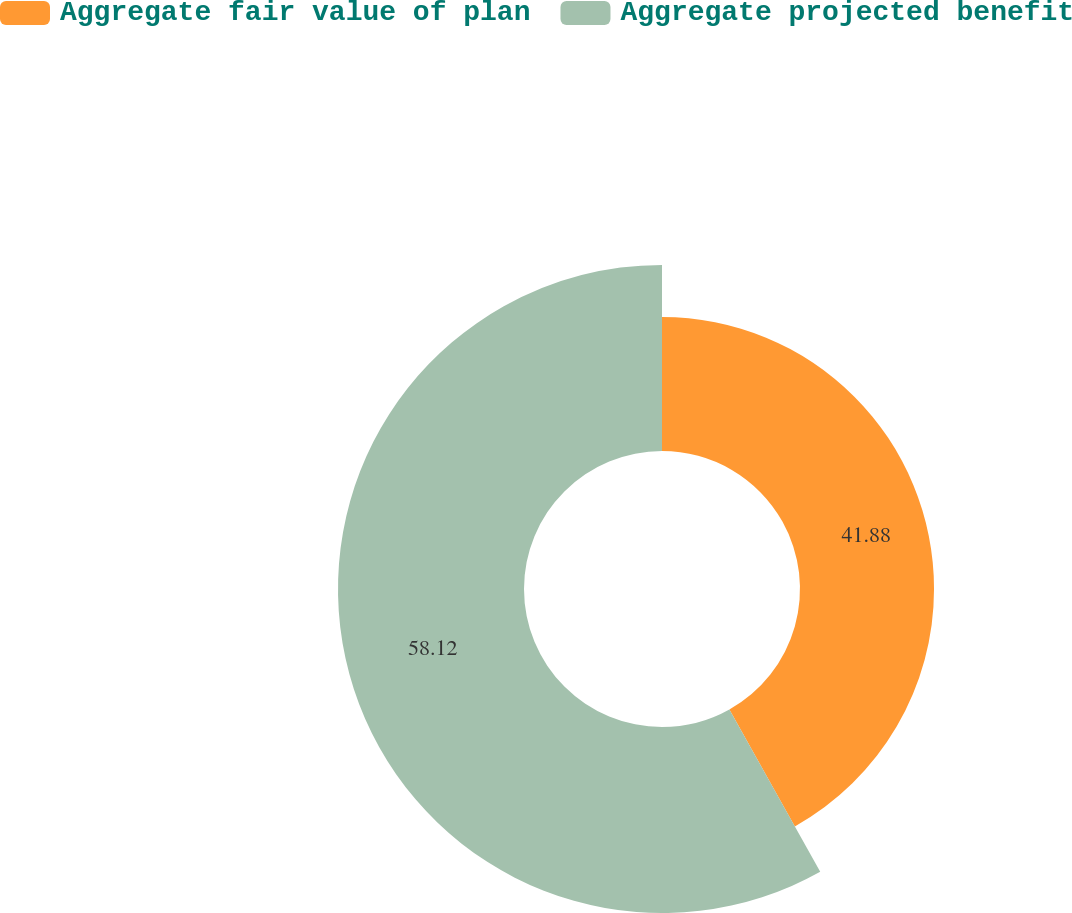Convert chart to OTSL. <chart><loc_0><loc_0><loc_500><loc_500><pie_chart><fcel>Aggregate fair value of plan<fcel>Aggregate projected benefit<nl><fcel>41.88%<fcel>58.12%<nl></chart> 